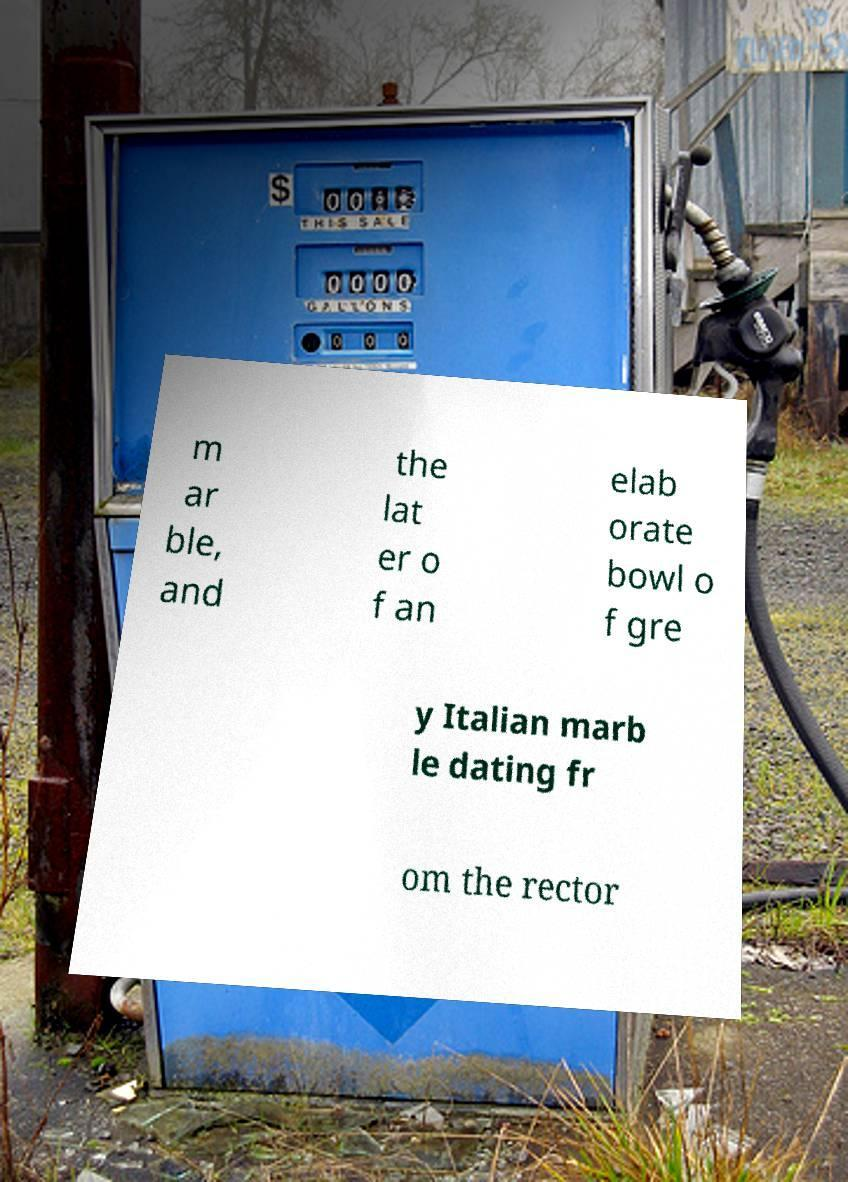Can you read and provide the text displayed in the image?This photo seems to have some interesting text. Can you extract and type it out for me? m ar ble, and the lat er o f an elab orate bowl o f gre y Italian marb le dating fr om the rector 